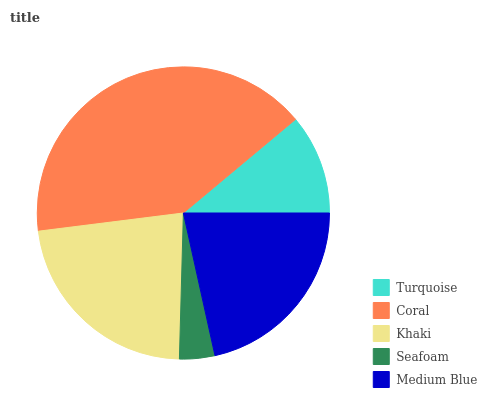Is Seafoam the minimum?
Answer yes or no. Yes. Is Coral the maximum?
Answer yes or no. Yes. Is Khaki the minimum?
Answer yes or no. No. Is Khaki the maximum?
Answer yes or no. No. Is Coral greater than Khaki?
Answer yes or no. Yes. Is Khaki less than Coral?
Answer yes or no. Yes. Is Khaki greater than Coral?
Answer yes or no. No. Is Coral less than Khaki?
Answer yes or no. No. Is Medium Blue the high median?
Answer yes or no. Yes. Is Medium Blue the low median?
Answer yes or no. Yes. Is Seafoam the high median?
Answer yes or no. No. Is Turquoise the low median?
Answer yes or no. No. 